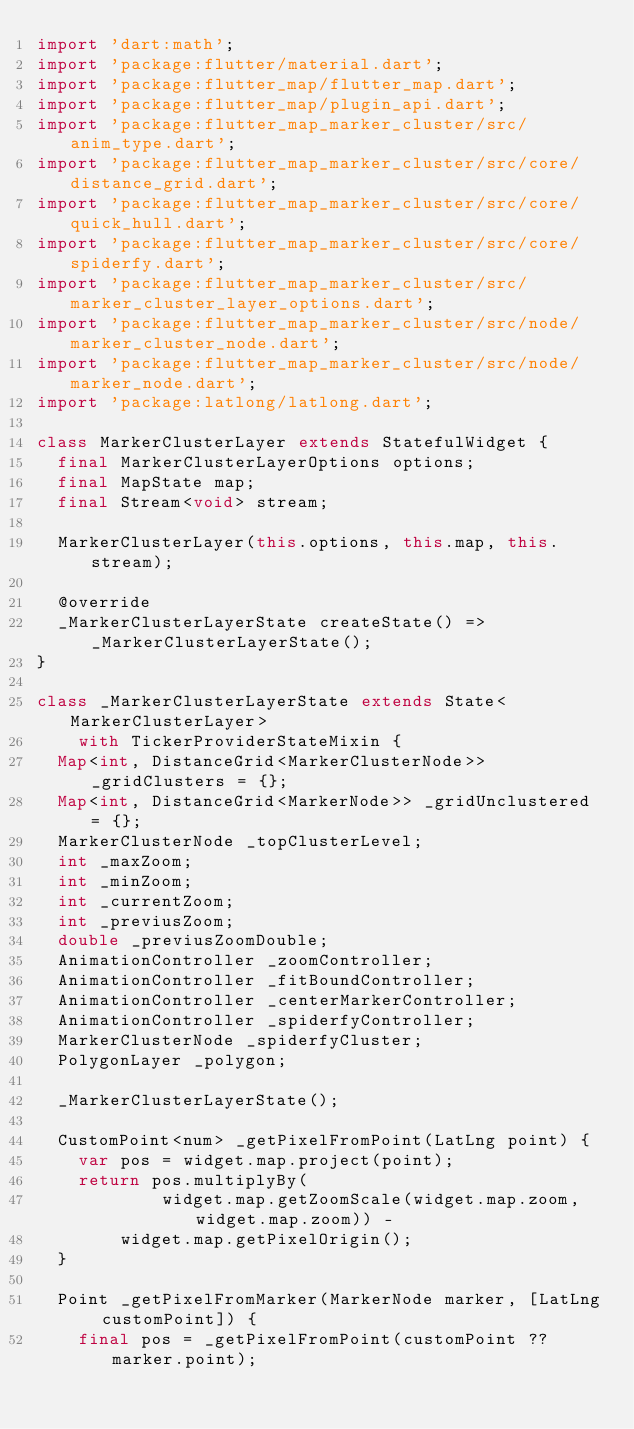<code> <loc_0><loc_0><loc_500><loc_500><_Dart_>import 'dart:math';
import 'package:flutter/material.dart';
import 'package:flutter_map/flutter_map.dart';
import 'package:flutter_map/plugin_api.dart';
import 'package:flutter_map_marker_cluster/src/anim_type.dart';
import 'package:flutter_map_marker_cluster/src/core/distance_grid.dart';
import 'package:flutter_map_marker_cluster/src/core/quick_hull.dart';
import 'package:flutter_map_marker_cluster/src/core/spiderfy.dart';
import 'package:flutter_map_marker_cluster/src/marker_cluster_layer_options.dart';
import 'package:flutter_map_marker_cluster/src/node/marker_cluster_node.dart';
import 'package:flutter_map_marker_cluster/src/node/marker_node.dart';
import 'package:latlong/latlong.dart';

class MarkerClusterLayer extends StatefulWidget {
  final MarkerClusterLayerOptions options;
  final MapState map;
  final Stream<void> stream;

  MarkerClusterLayer(this.options, this.map, this.stream);

  @override
  _MarkerClusterLayerState createState() => _MarkerClusterLayerState();
}

class _MarkerClusterLayerState extends State<MarkerClusterLayer>
    with TickerProviderStateMixin {
  Map<int, DistanceGrid<MarkerClusterNode>> _gridClusters = {};
  Map<int, DistanceGrid<MarkerNode>> _gridUnclustered = {};
  MarkerClusterNode _topClusterLevel;
  int _maxZoom;
  int _minZoom;
  int _currentZoom;
  int _previusZoom;
  double _previusZoomDouble;
  AnimationController _zoomController;
  AnimationController _fitBoundController;
  AnimationController _centerMarkerController;
  AnimationController _spiderfyController;
  MarkerClusterNode _spiderfyCluster;
  PolygonLayer _polygon;

  _MarkerClusterLayerState();

  CustomPoint<num> _getPixelFromPoint(LatLng point) {
    var pos = widget.map.project(point);
    return pos.multiplyBy(
            widget.map.getZoomScale(widget.map.zoom, widget.map.zoom)) -
        widget.map.getPixelOrigin();
  }

  Point _getPixelFromMarker(MarkerNode marker, [LatLng customPoint]) {
    final pos = _getPixelFromPoint(customPoint ?? marker.point);</code> 